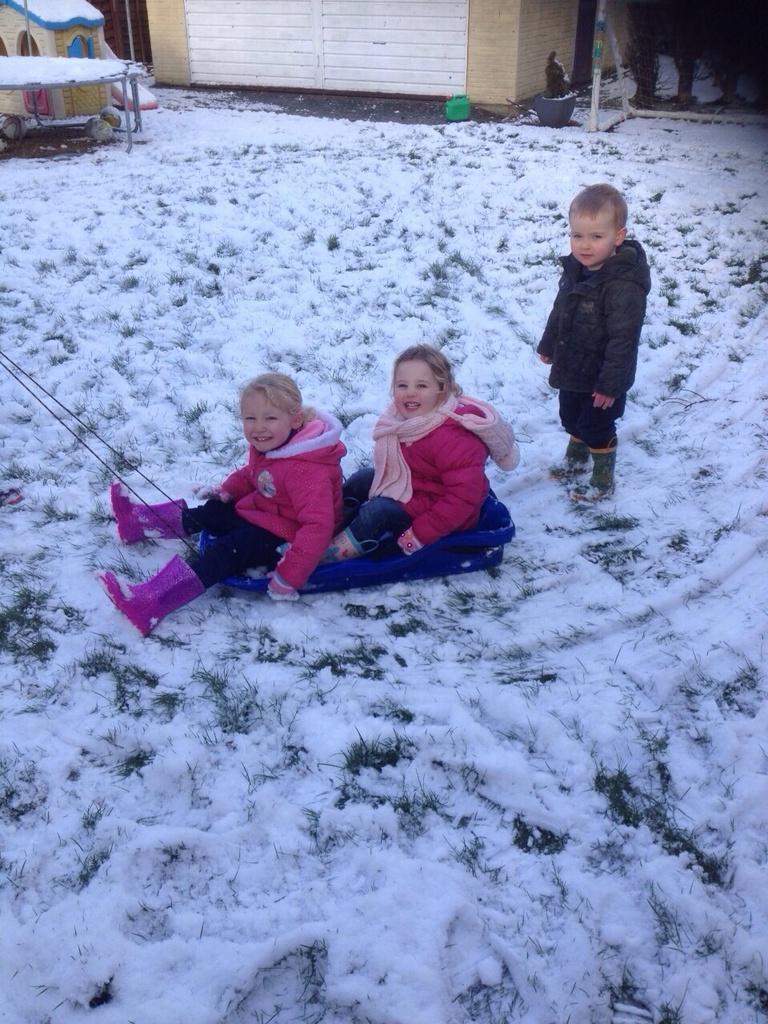How would you summarize this image in a sentence or two? In this image, there are a few people. Among them, two people are sitting on a blue colored object. We can see the ground covered with snow and some grass. We can also see a trampoline, a house and the wall with a white colored object. We can also see some objects. We can see some poles. 